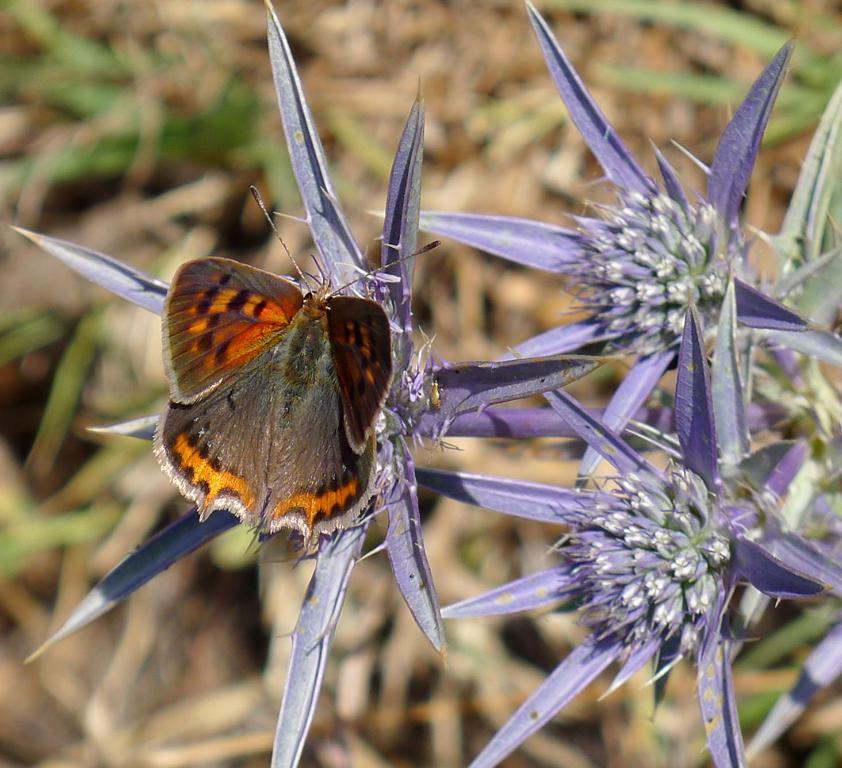Could you give a brief overview of what you see in this image? In this picture i can see a bug is sitting on a flowers. The background of the image is blur. 